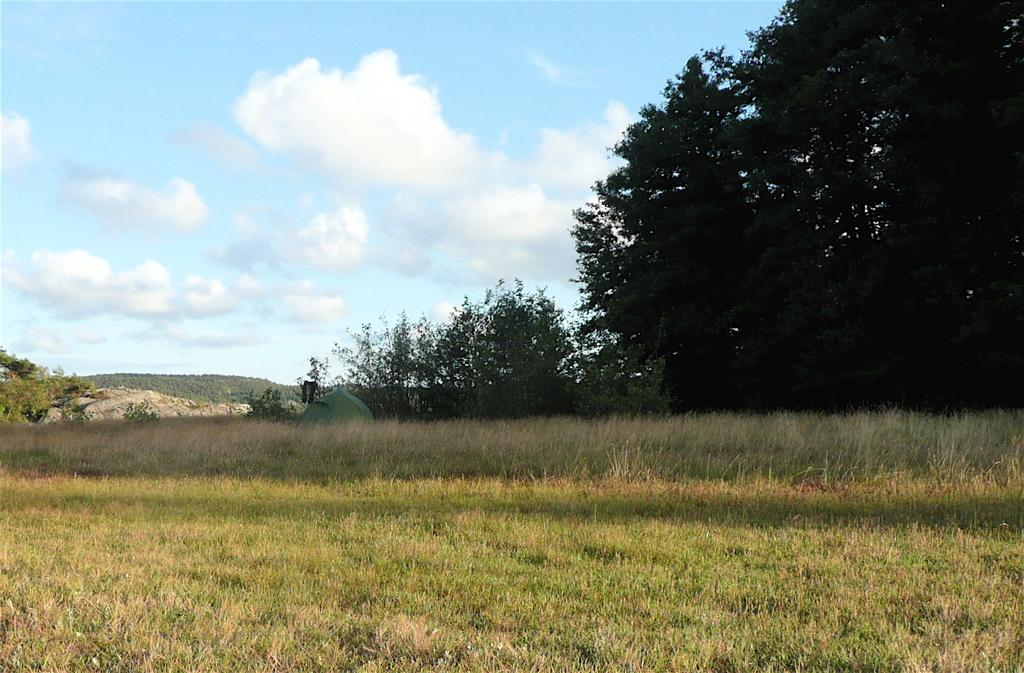What type of vegetation is present in the image? There is grass in the image. Where are the trees located in the image? The trees are on the right side of the image. What can be seen in the sky in the background of the image? There are clouds visible in the sky in the background of the image. Where is the cart located in the image? There is no cart present in the image. What type of insect can be seen on the grass in the image? There is no insect, such as a ladybug, present in the image. 